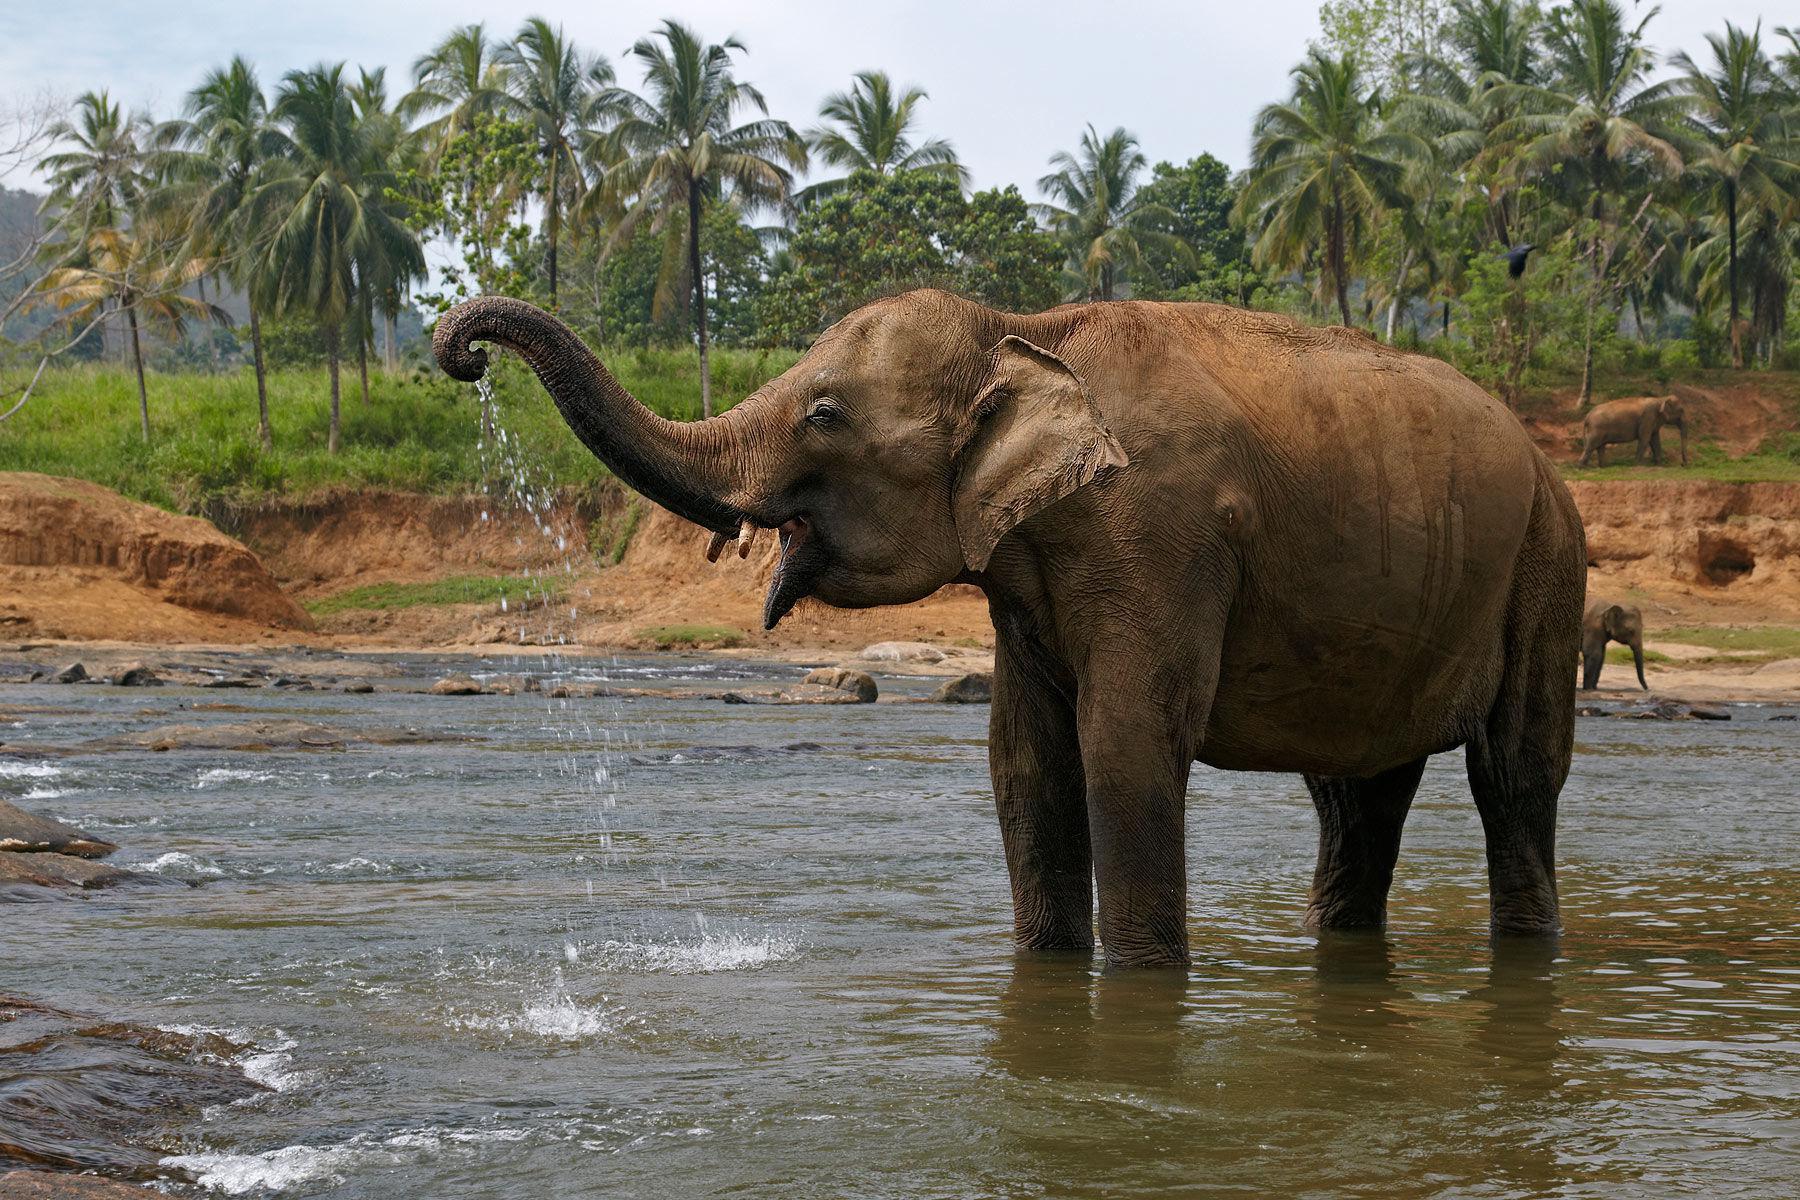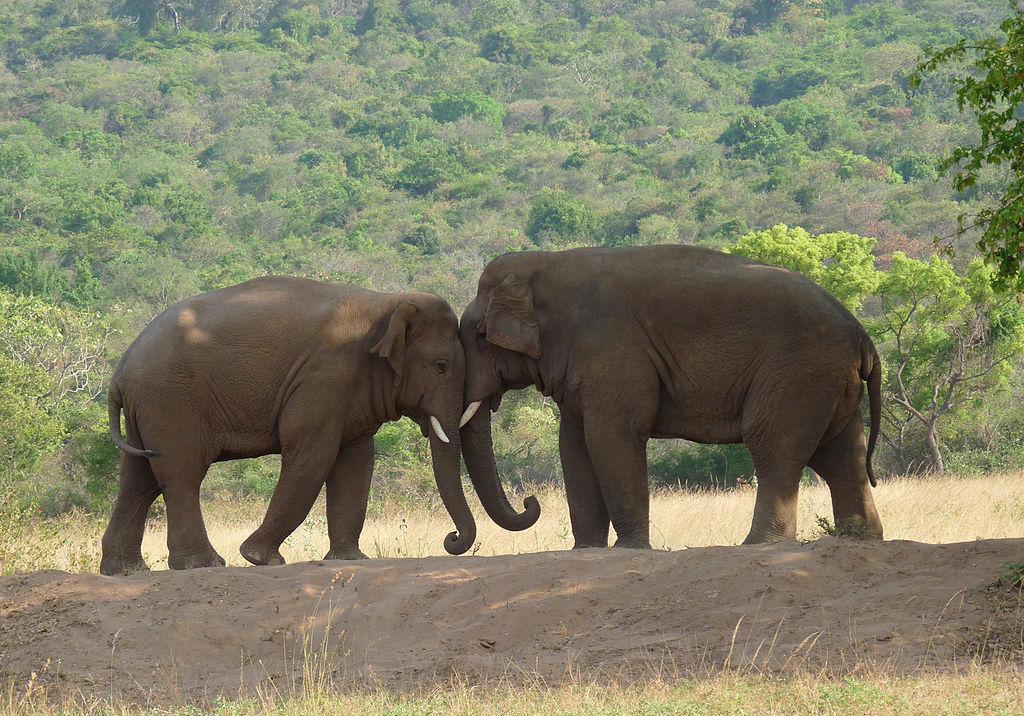The first image is the image on the left, the second image is the image on the right. Considering the images on both sides, is "There is exactly one elephant in the image on the right." valid? Answer yes or no. No. 